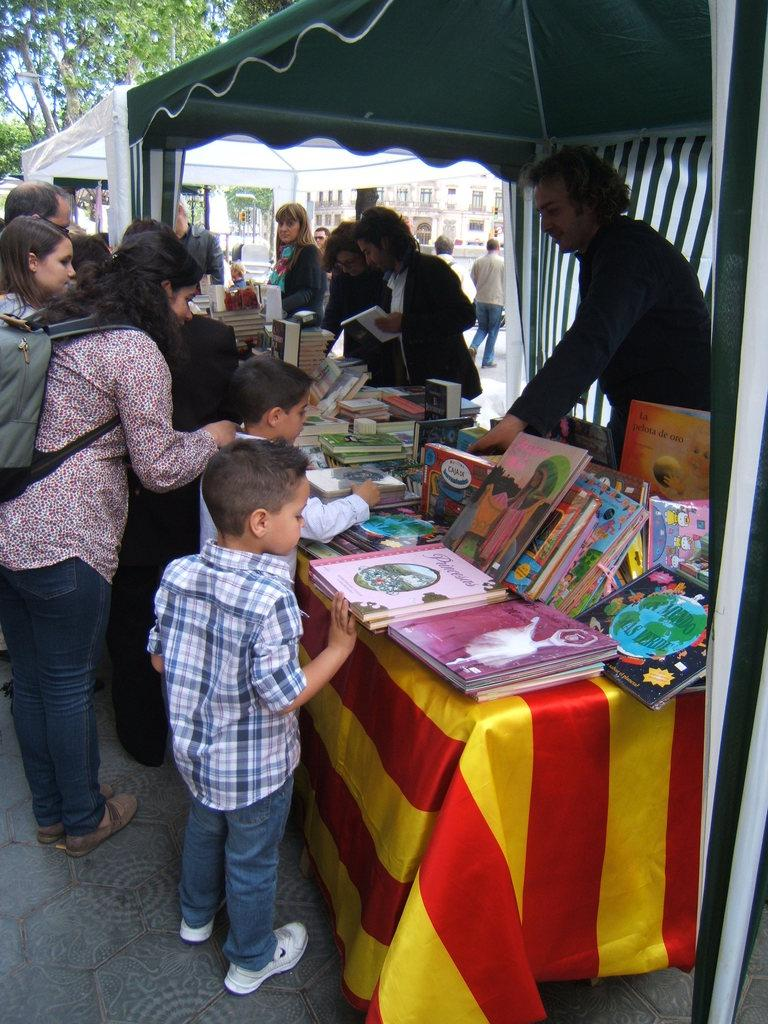What are the people in the image doing? The persons standing on the floor are likely engaged in some activity or conversation. What object can be seen in the image besides the people? There is a table in the image. What is on the table? There are books on the table. What can be seen in the distance in the image? There is a building and a tree in the background of the image. What type of lock is used to secure the books on the table? There is no lock present on the books or the table in the image. What type of brush is being used by the persons in the image? There is no brush visible in the image; the persons are not engaged in any activity that would require a brush. 